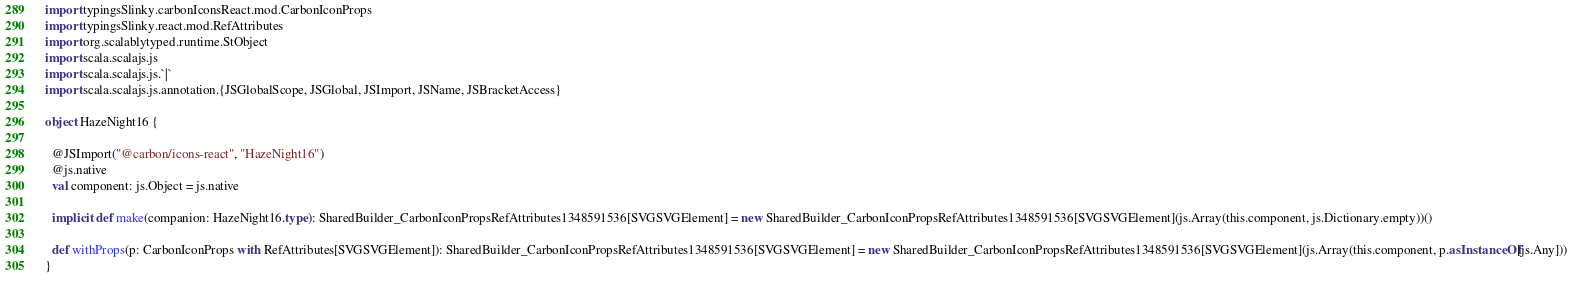<code> <loc_0><loc_0><loc_500><loc_500><_Scala_>import typingsSlinky.carbonIconsReact.mod.CarbonIconProps
import typingsSlinky.react.mod.RefAttributes
import org.scalablytyped.runtime.StObject
import scala.scalajs.js
import scala.scalajs.js.`|`
import scala.scalajs.js.annotation.{JSGlobalScope, JSGlobal, JSImport, JSName, JSBracketAccess}

object HazeNight16 {
  
  @JSImport("@carbon/icons-react", "HazeNight16")
  @js.native
  val component: js.Object = js.native
  
  implicit def make(companion: HazeNight16.type): SharedBuilder_CarbonIconPropsRefAttributes1348591536[SVGSVGElement] = new SharedBuilder_CarbonIconPropsRefAttributes1348591536[SVGSVGElement](js.Array(this.component, js.Dictionary.empty))()
  
  def withProps(p: CarbonIconProps with RefAttributes[SVGSVGElement]): SharedBuilder_CarbonIconPropsRefAttributes1348591536[SVGSVGElement] = new SharedBuilder_CarbonIconPropsRefAttributes1348591536[SVGSVGElement](js.Array(this.component, p.asInstanceOf[js.Any]))
}
</code> 